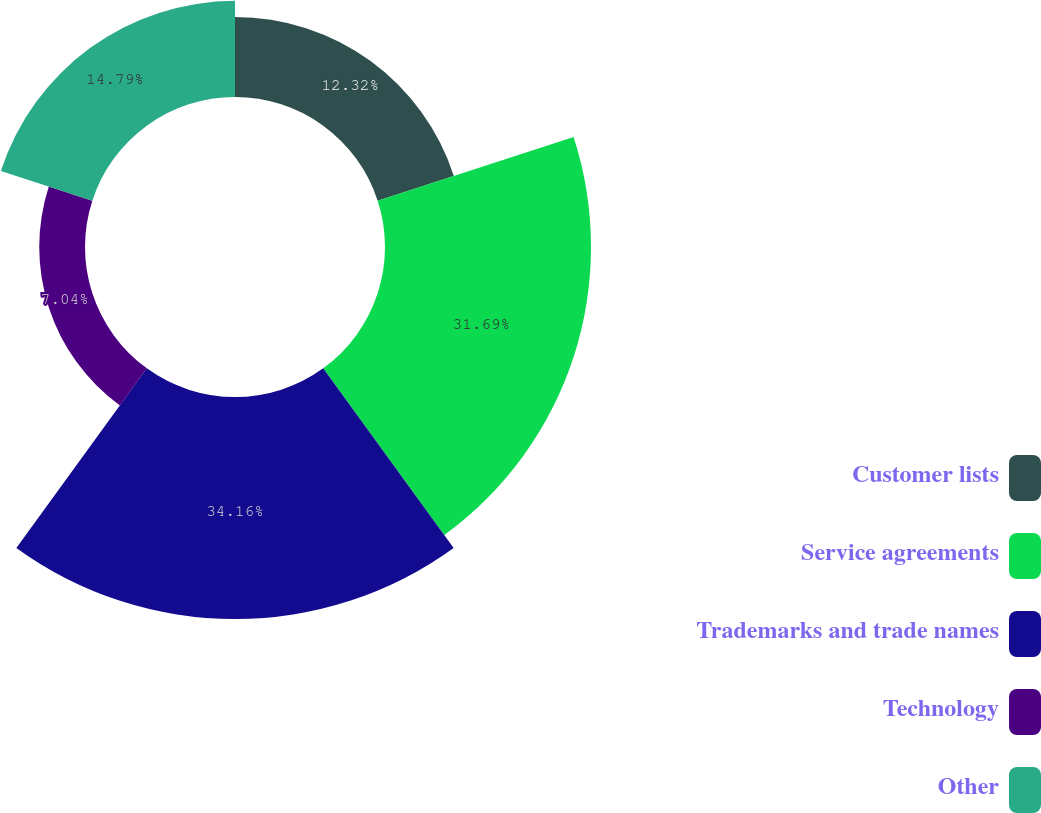<chart> <loc_0><loc_0><loc_500><loc_500><pie_chart><fcel>Customer lists<fcel>Service agreements<fcel>Trademarks and trade names<fcel>Technology<fcel>Other<nl><fcel>12.32%<fcel>31.69%<fcel>34.15%<fcel>7.04%<fcel>14.79%<nl></chart> 